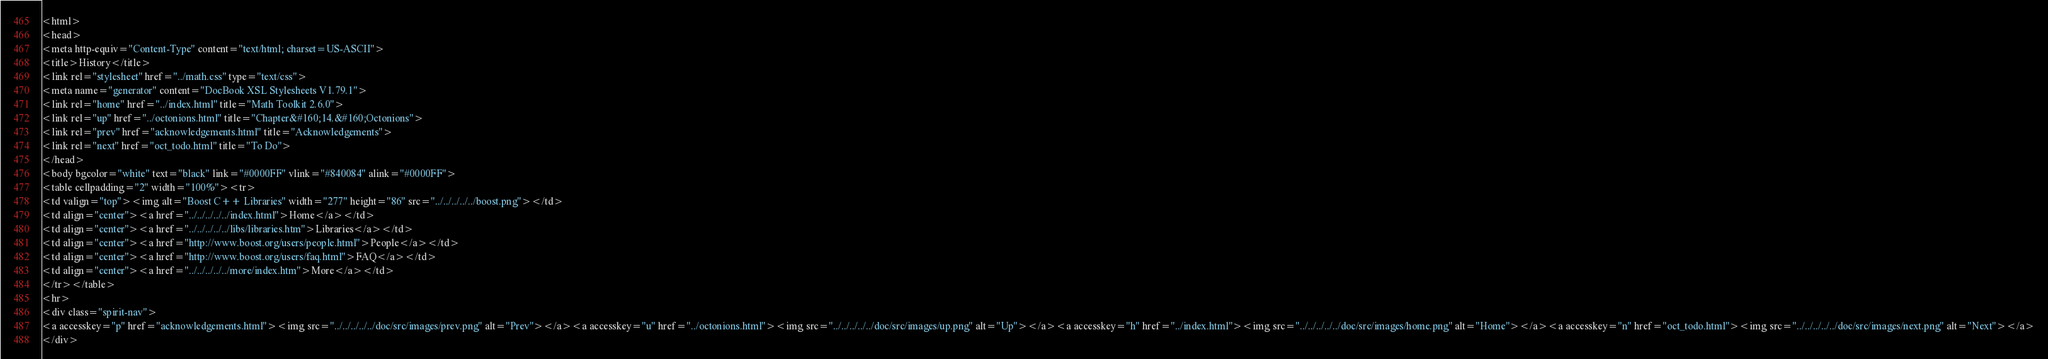<code> <loc_0><loc_0><loc_500><loc_500><_HTML_><html>
<head>
<meta http-equiv="Content-Type" content="text/html; charset=US-ASCII">
<title>History</title>
<link rel="stylesheet" href="../math.css" type="text/css">
<meta name="generator" content="DocBook XSL Stylesheets V1.79.1">
<link rel="home" href="../index.html" title="Math Toolkit 2.6.0">
<link rel="up" href="../octonions.html" title="Chapter&#160;14.&#160;Octonions">
<link rel="prev" href="acknowledgements.html" title="Acknowledgements">
<link rel="next" href="oct_todo.html" title="To Do">
</head>
<body bgcolor="white" text="black" link="#0000FF" vlink="#840084" alink="#0000FF">
<table cellpadding="2" width="100%"><tr>
<td valign="top"><img alt="Boost C++ Libraries" width="277" height="86" src="../../../../../boost.png"></td>
<td align="center"><a href="../../../../../index.html">Home</a></td>
<td align="center"><a href="../../../../../libs/libraries.htm">Libraries</a></td>
<td align="center"><a href="http://www.boost.org/users/people.html">People</a></td>
<td align="center"><a href="http://www.boost.org/users/faq.html">FAQ</a></td>
<td align="center"><a href="../../../../../more/index.htm">More</a></td>
</tr></table>
<hr>
<div class="spirit-nav">
<a accesskey="p" href="acknowledgements.html"><img src="../../../../../doc/src/images/prev.png" alt="Prev"></a><a accesskey="u" href="../octonions.html"><img src="../../../../../doc/src/images/up.png" alt="Up"></a><a accesskey="h" href="../index.html"><img src="../../../../../doc/src/images/home.png" alt="Home"></a><a accesskey="n" href="oct_todo.html"><img src="../../../../../doc/src/images/next.png" alt="Next"></a>
</div></code> 